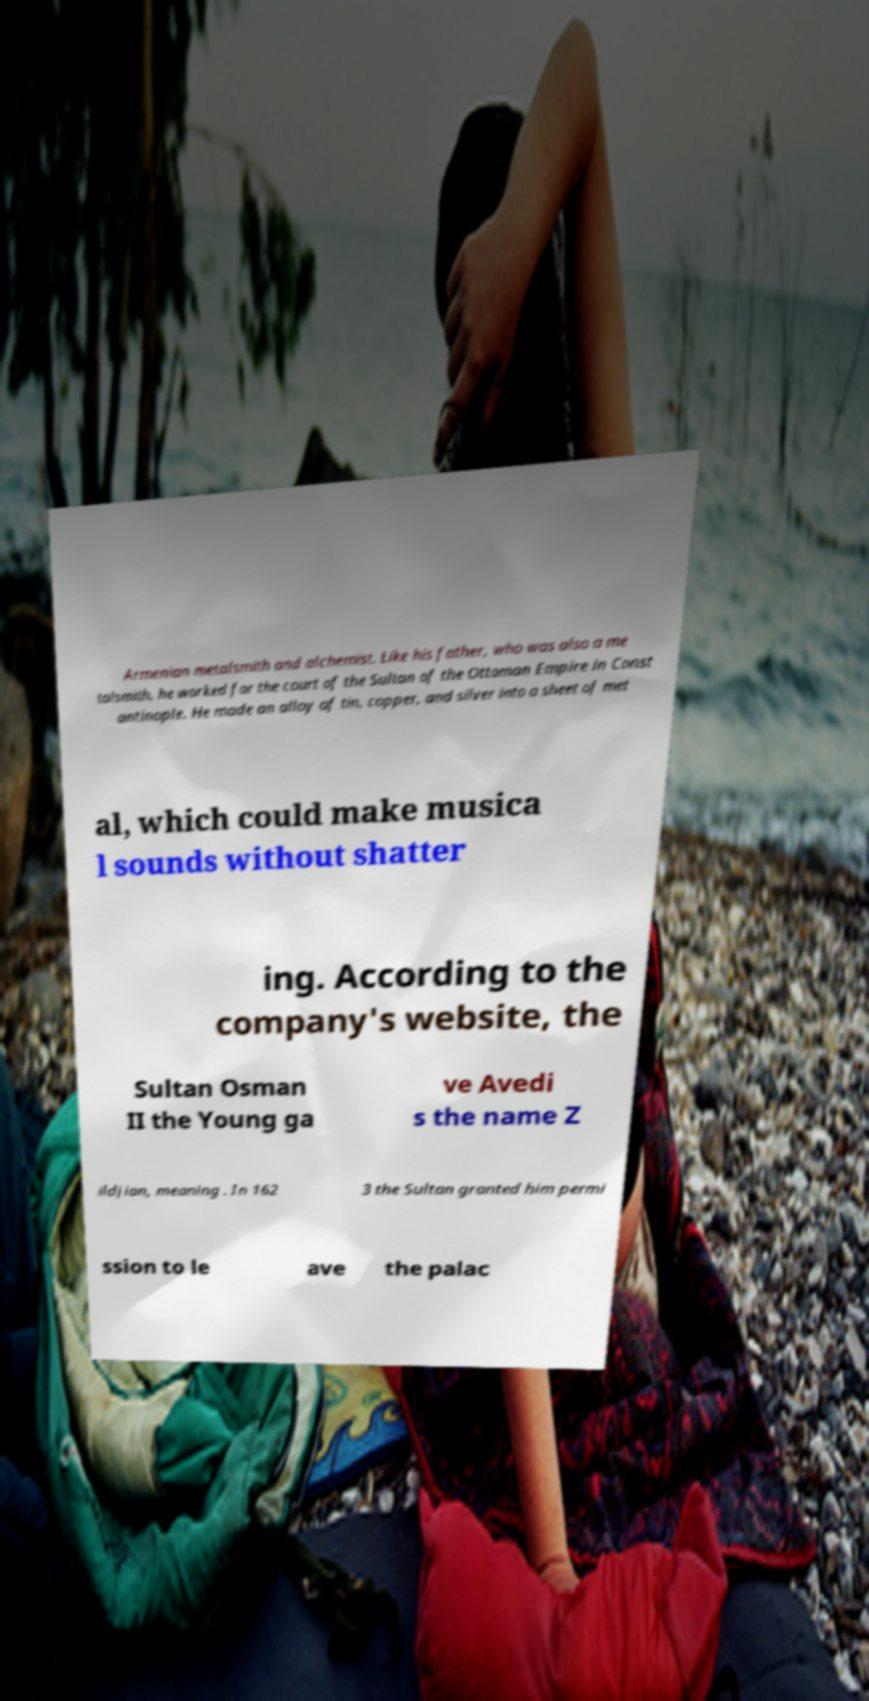Please identify and transcribe the text found in this image. Armenian metalsmith and alchemist. Like his father, who was also a me talsmith, he worked for the court of the Sultan of the Ottoman Empire in Const antinople. He made an alloy of tin, copper, and silver into a sheet of met al, which could make musica l sounds without shatter ing. According to the company's website, the Sultan Osman II the Young ga ve Avedi s the name Z ildjian, meaning . In 162 3 the Sultan granted him permi ssion to le ave the palac 